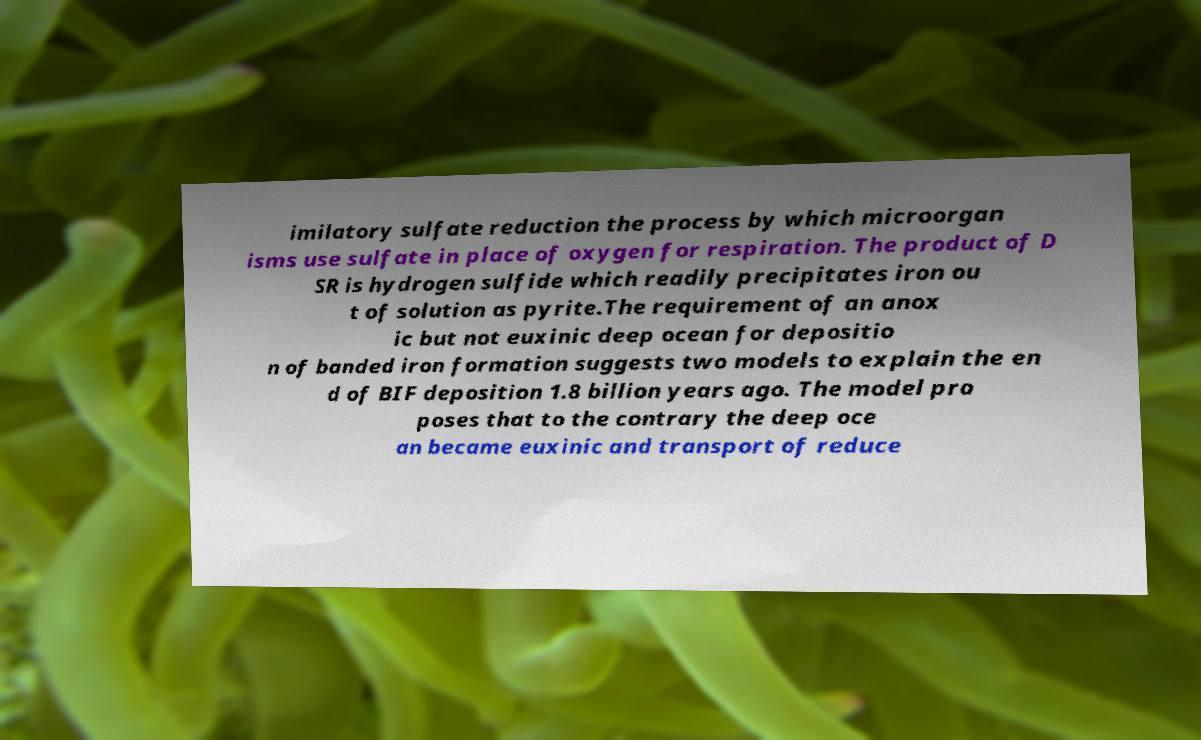Please read and relay the text visible in this image. What does it say? imilatory sulfate reduction the process by which microorgan isms use sulfate in place of oxygen for respiration. The product of D SR is hydrogen sulfide which readily precipitates iron ou t of solution as pyrite.The requirement of an anox ic but not euxinic deep ocean for depositio n of banded iron formation suggests two models to explain the en d of BIF deposition 1.8 billion years ago. The model pro poses that to the contrary the deep oce an became euxinic and transport of reduce 